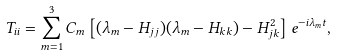<formula> <loc_0><loc_0><loc_500><loc_500>T _ { i i } = \sum _ { m = 1 } ^ { 3 } C _ { m } \left [ ( \lambda _ { m } - H _ { j j } ) ( \lambda _ { m } - H _ { k k } ) - H _ { j k } ^ { 2 } \right ] e ^ { - i \lambda _ { m } t } ,</formula> 